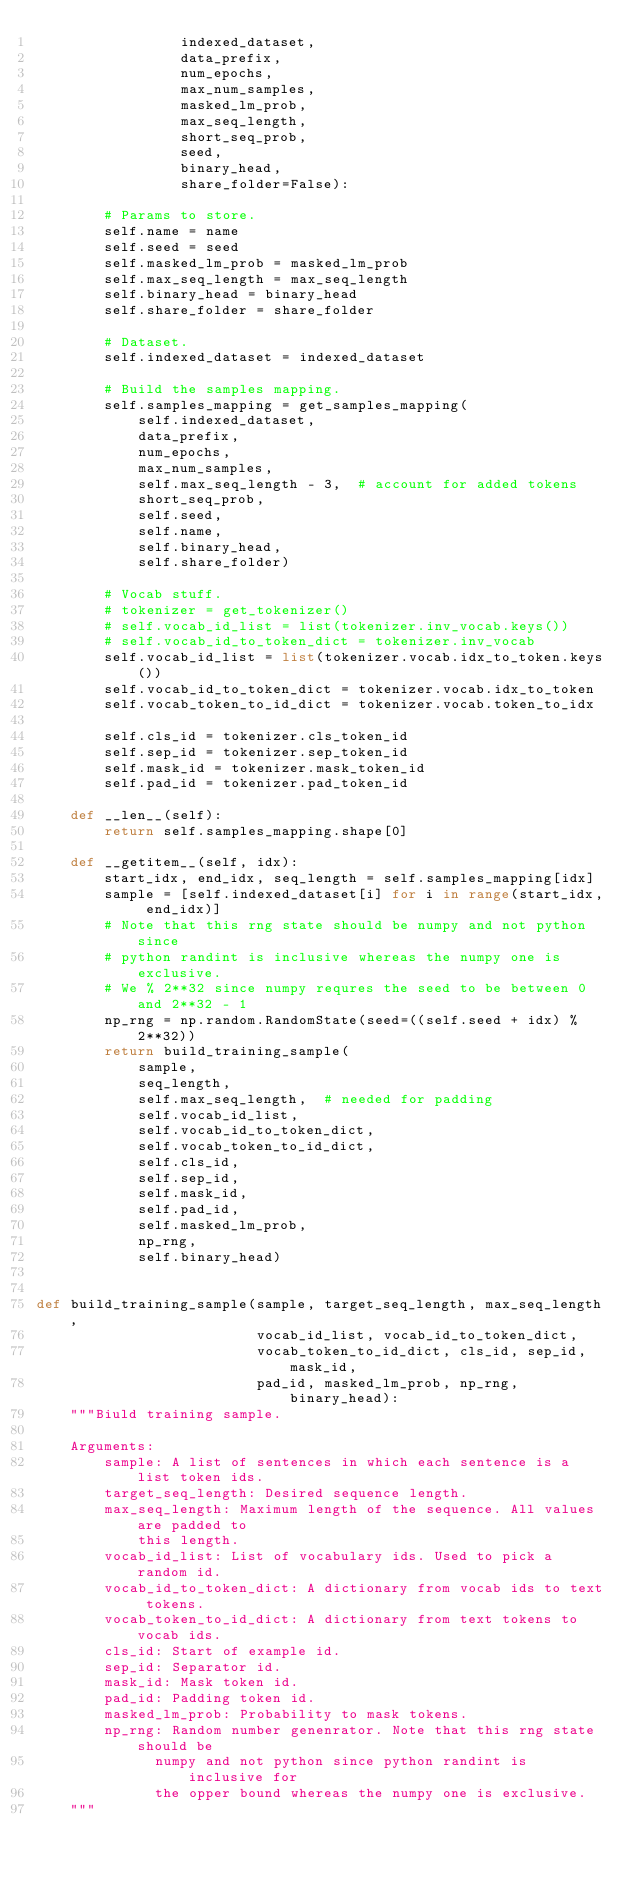Convert code to text. <code><loc_0><loc_0><loc_500><loc_500><_Python_>                 indexed_dataset,
                 data_prefix,
                 num_epochs,
                 max_num_samples,
                 masked_lm_prob,
                 max_seq_length,
                 short_seq_prob,
                 seed,
                 binary_head,
                 share_folder=False):

        # Params to store.
        self.name = name
        self.seed = seed
        self.masked_lm_prob = masked_lm_prob
        self.max_seq_length = max_seq_length
        self.binary_head = binary_head
        self.share_folder = share_folder

        # Dataset.
        self.indexed_dataset = indexed_dataset

        # Build the samples mapping.
        self.samples_mapping = get_samples_mapping(
            self.indexed_dataset,
            data_prefix,
            num_epochs,
            max_num_samples,
            self.max_seq_length - 3,  # account for added tokens
            short_seq_prob,
            self.seed,
            self.name,
            self.binary_head,
            self.share_folder)

        # Vocab stuff.
        # tokenizer = get_tokenizer()
        # self.vocab_id_list = list(tokenizer.inv_vocab.keys())
        # self.vocab_id_to_token_dict = tokenizer.inv_vocab
        self.vocab_id_list = list(tokenizer.vocab.idx_to_token.keys())
        self.vocab_id_to_token_dict = tokenizer.vocab.idx_to_token
        self.vocab_token_to_id_dict = tokenizer.vocab.token_to_idx

        self.cls_id = tokenizer.cls_token_id
        self.sep_id = tokenizer.sep_token_id
        self.mask_id = tokenizer.mask_token_id
        self.pad_id = tokenizer.pad_token_id

    def __len__(self):
        return self.samples_mapping.shape[0]

    def __getitem__(self, idx):
        start_idx, end_idx, seq_length = self.samples_mapping[idx]
        sample = [self.indexed_dataset[i] for i in range(start_idx, end_idx)]
        # Note that this rng state should be numpy and not python since
        # python randint is inclusive whereas the numpy one is exclusive.
        # We % 2**32 since numpy requres the seed to be between 0 and 2**32 - 1
        np_rng = np.random.RandomState(seed=((self.seed + idx) % 2**32))
        return build_training_sample(
            sample,
            seq_length,
            self.max_seq_length,  # needed for padding
            self.vocab_id_list,
            self.vocab_id_to_token_dict,
            self.vocab_token_to_id_dict,
            self.cls_id,
            self.sep_id,
            self.mask_id,
            self.pad_id,
            self.masked_lm_prob,
            np_rng,
            self.binary_head)


def build_training_sample(sample, target_seq_length, max_seq_length,
                          vocab_id_list, vocab_id_to_token_dict,
                          vocab_token_to_id_dict, cls_id, sep_id, mask_id,
                          pad_id, masked_lm_prob, np_rng, binary_head):
    """Biuld training sample.

    Arguments:
        sample: A list of sentences in which each sentence is a list token ids.
        target_seq_length: Desired sequence length.
        max_seq_length: Maximum length of the sequence. All values are padded to
            this length.
        vocab_id_list: List of vocabulary ids. Used to pick a random id.
        vocab_id_to_token_dict: A dictionary from vocab ids to text tokens.
        vocab_token_to_id_dict: A dictionary from text tokens to vocab ids.
        cls_id: Start of example id.
        sep_id: Separator id.
        mask_id: Mask token id.
        pad_id: Padding token id.
        masked_lm_prob: Probability to mask tokens.
        np_rng: Random number genenrator. Note that this rng state should be
              numpy and not python since python randint is inclusive for
              the opper bound whereas the numpy one is exclusive.
    """
</code> 